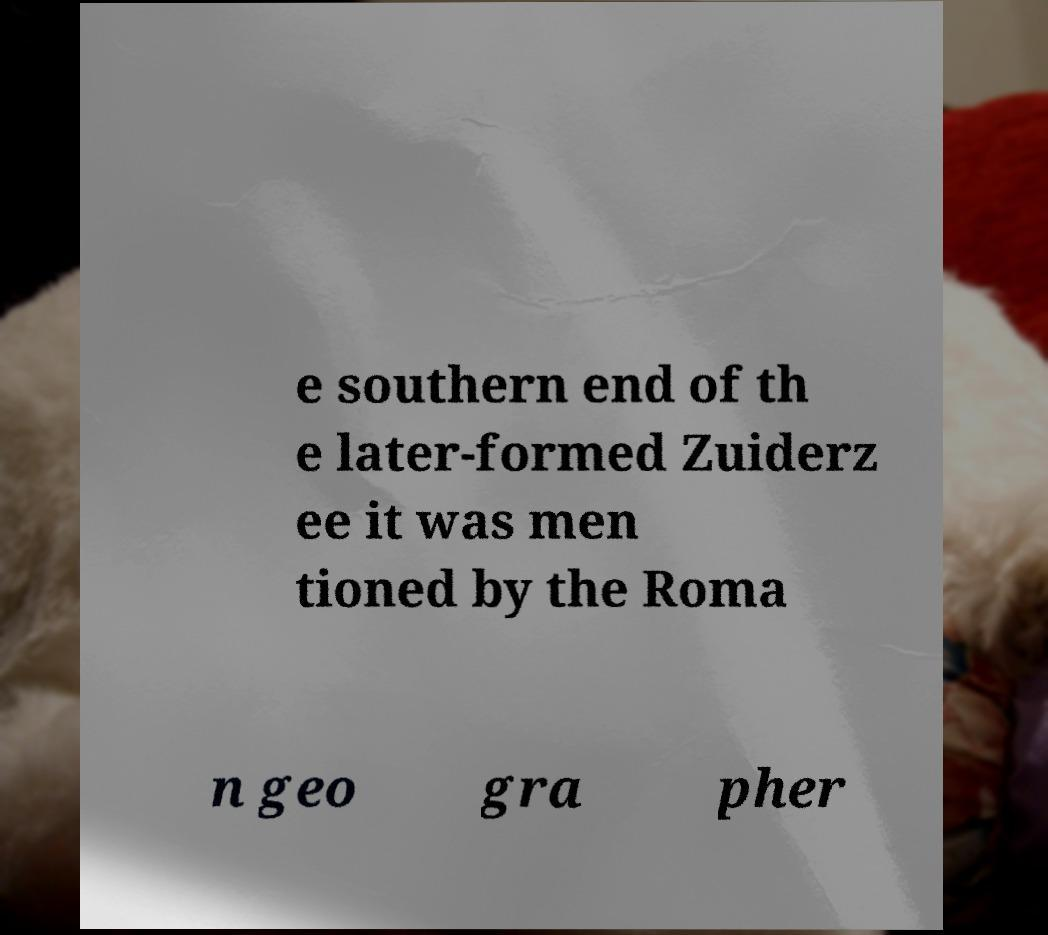Please identify and transcribe the text found in this image. e southern end of th e later-formed Zuiderz ee it was men tioned by the Roma n geo gra pher 